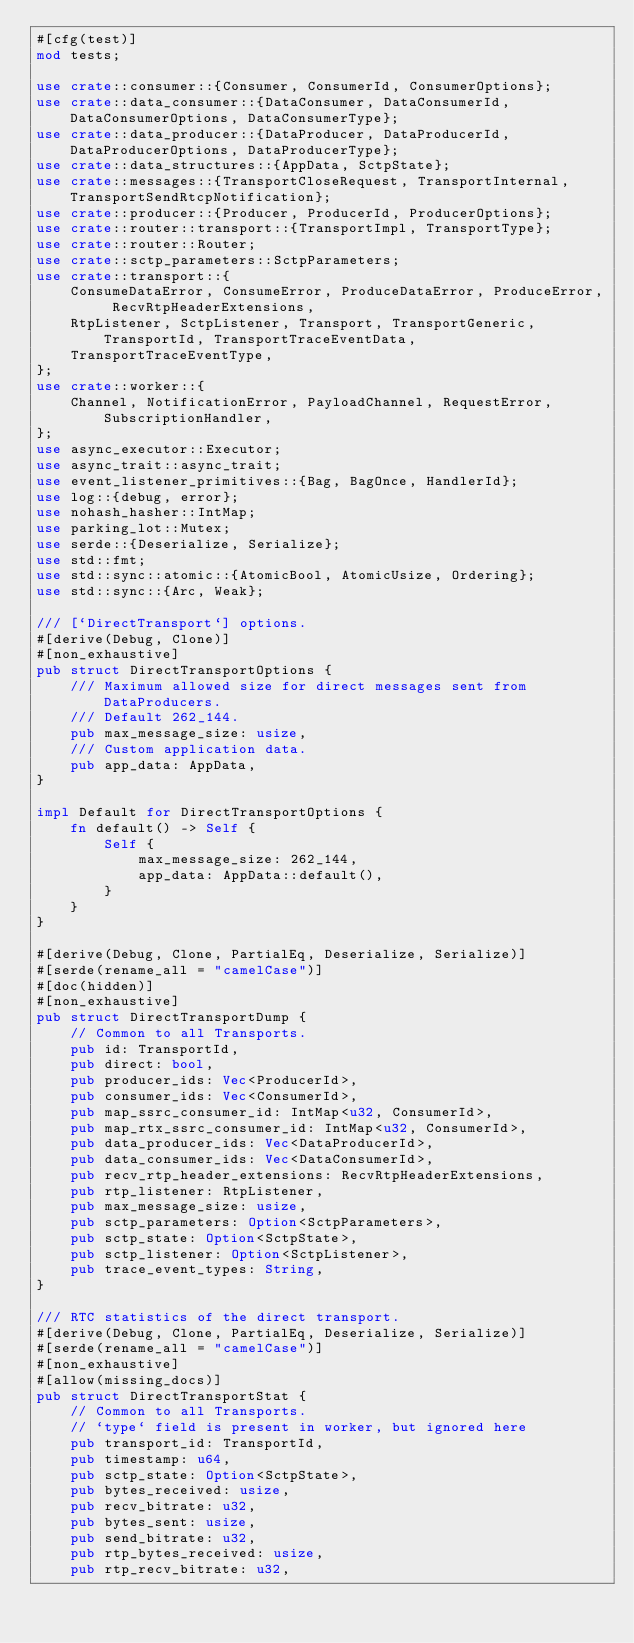Convert code to text. <code><loc_0><loc_0><loc_500><loc_500><_Rust_>#[cfg(test)]
mod tests;

use crate::consumer::{Consumer, ConsumerId, ConsumerOptions};
use crate::data_consumer::{DataConsumer, DataConsumerId, DataConsumerOptions, DataConsumerType};
use crate::data_producer::{DataProducer, DataProducerId, DataProducerOptions, DataProducerType};
use crate::data_structures::{AppData, SctpState};
use crate::messages::{TransportCloseRequest, TransportInternal, TransportSendRtcpNotification};
use crate::producer::{Producer, ProducerId, ProducerOptions};
use crate::router::transport::{TransportImpl, TransportType};
use crate::router::Router;
use crate::sctp_parameters::SctpParameters;
use crate::transport::{
    ConsumeDataError, ConsumeError, ProduceDataError, ProduceError, RecvRtpHeaderExtensions,
    RtpListener, SctpListener, Transport, TransportGeneric, TransportId, TransportTraceEventData,
    TransportTraceEventType,
};
use crate::worker::{
    Channel, NotificationError, PayloadChannel, RequestError, SubscriptionHandler,
};
use async_executor::Executor;
use async_trait::async_trait;
use event_listener_primitives::{Bag, BagOnce, HandlerId};
use log::{debug, error};
use nohash_hasher::IntMap;
use parking_lot::Mutex;
use serde::{Deserialize, Serialize};
use std::fmt;
use std::sync::atomic::{AtomicBool, AtomicUsize, Ordering};
use std::sync::{Arc, Weak};

/// [`DirectTransport`] options.
#[derive(Debug, Clone)]
#[non_exhaustive]
pub struct DirectTransportOptions {
    /// Maximum allowed size for direct messages sent from DataProducers.
    /// Default 262_144.
    pub max_message_size: usize,
    /// Custom application data.
    pub app_data: AppData,
}

impl Default for DirectTransportOptions {
    fn default() -> Self {
        Self {
            max_message_size: 262_144,
            app_data: AppData::default(),
        }
    }
}

#[derive(Debug, Clone, PartialEq, Deserialize, Serialize)]
#[serde(rename_all = "camelCase")]
#[doc(hidden)]
#[non_exhaustive]
pub struct DirectTransportDump {
    // Common to all Transports.
    pub id: TransportId,
    pub direct: bool,
    pub producer_ids: Vec<ProducerId>,
    pub consumer_ids: Vec<ConsumerId>,
    pub map_ssrc_consumer_id: IntMap<u32, ConsumerId>,
    pub map_rtx_ssrc_consumer_id: IntMap<u32, ConsumerId>,
    pub data_producer_ids: Vec<DataProducerId>,
    pub data_consumer_ids: Vec<DataConsumerId>,
    pub recv_rtp_header_extensions: RecvRtpHeaderExtensions,
    pub rtp_listener: RtpListener,
    pub max_message_size: usize,
    pub sctp_parameters: Option<SctpParameters>,
    pub sctp_state: Option<SctpState>,
    pub sctp_listener: Option<SctpListener>,
    pub trace_event_types: String,
}

/// RTC statistics of the direct transport.
#[derive(Debug, Clone, PartialEq, Deserialize, Serialize)]
#[serde(rename_all = "camelCase")]
#[non_exhaustive]
#[allow(missing_docs)]
pub struct DirectTransportStat {
    // Common to all Transports.
    // `type` field is present in worker, but ignored here
    pub transport_id: TransportId,
    pub timestamp: u64,
    pub sctp_state: Option<SctpState>,
    pub bytes_received: usize,
    pub recv_bitrate: u32,
    pub bytes_sent: usize,
    pub send_bitrate: u32,
    pub rtp_bytes_received: usize,
    pub rtp_recv_bitrate: u32,</code> 